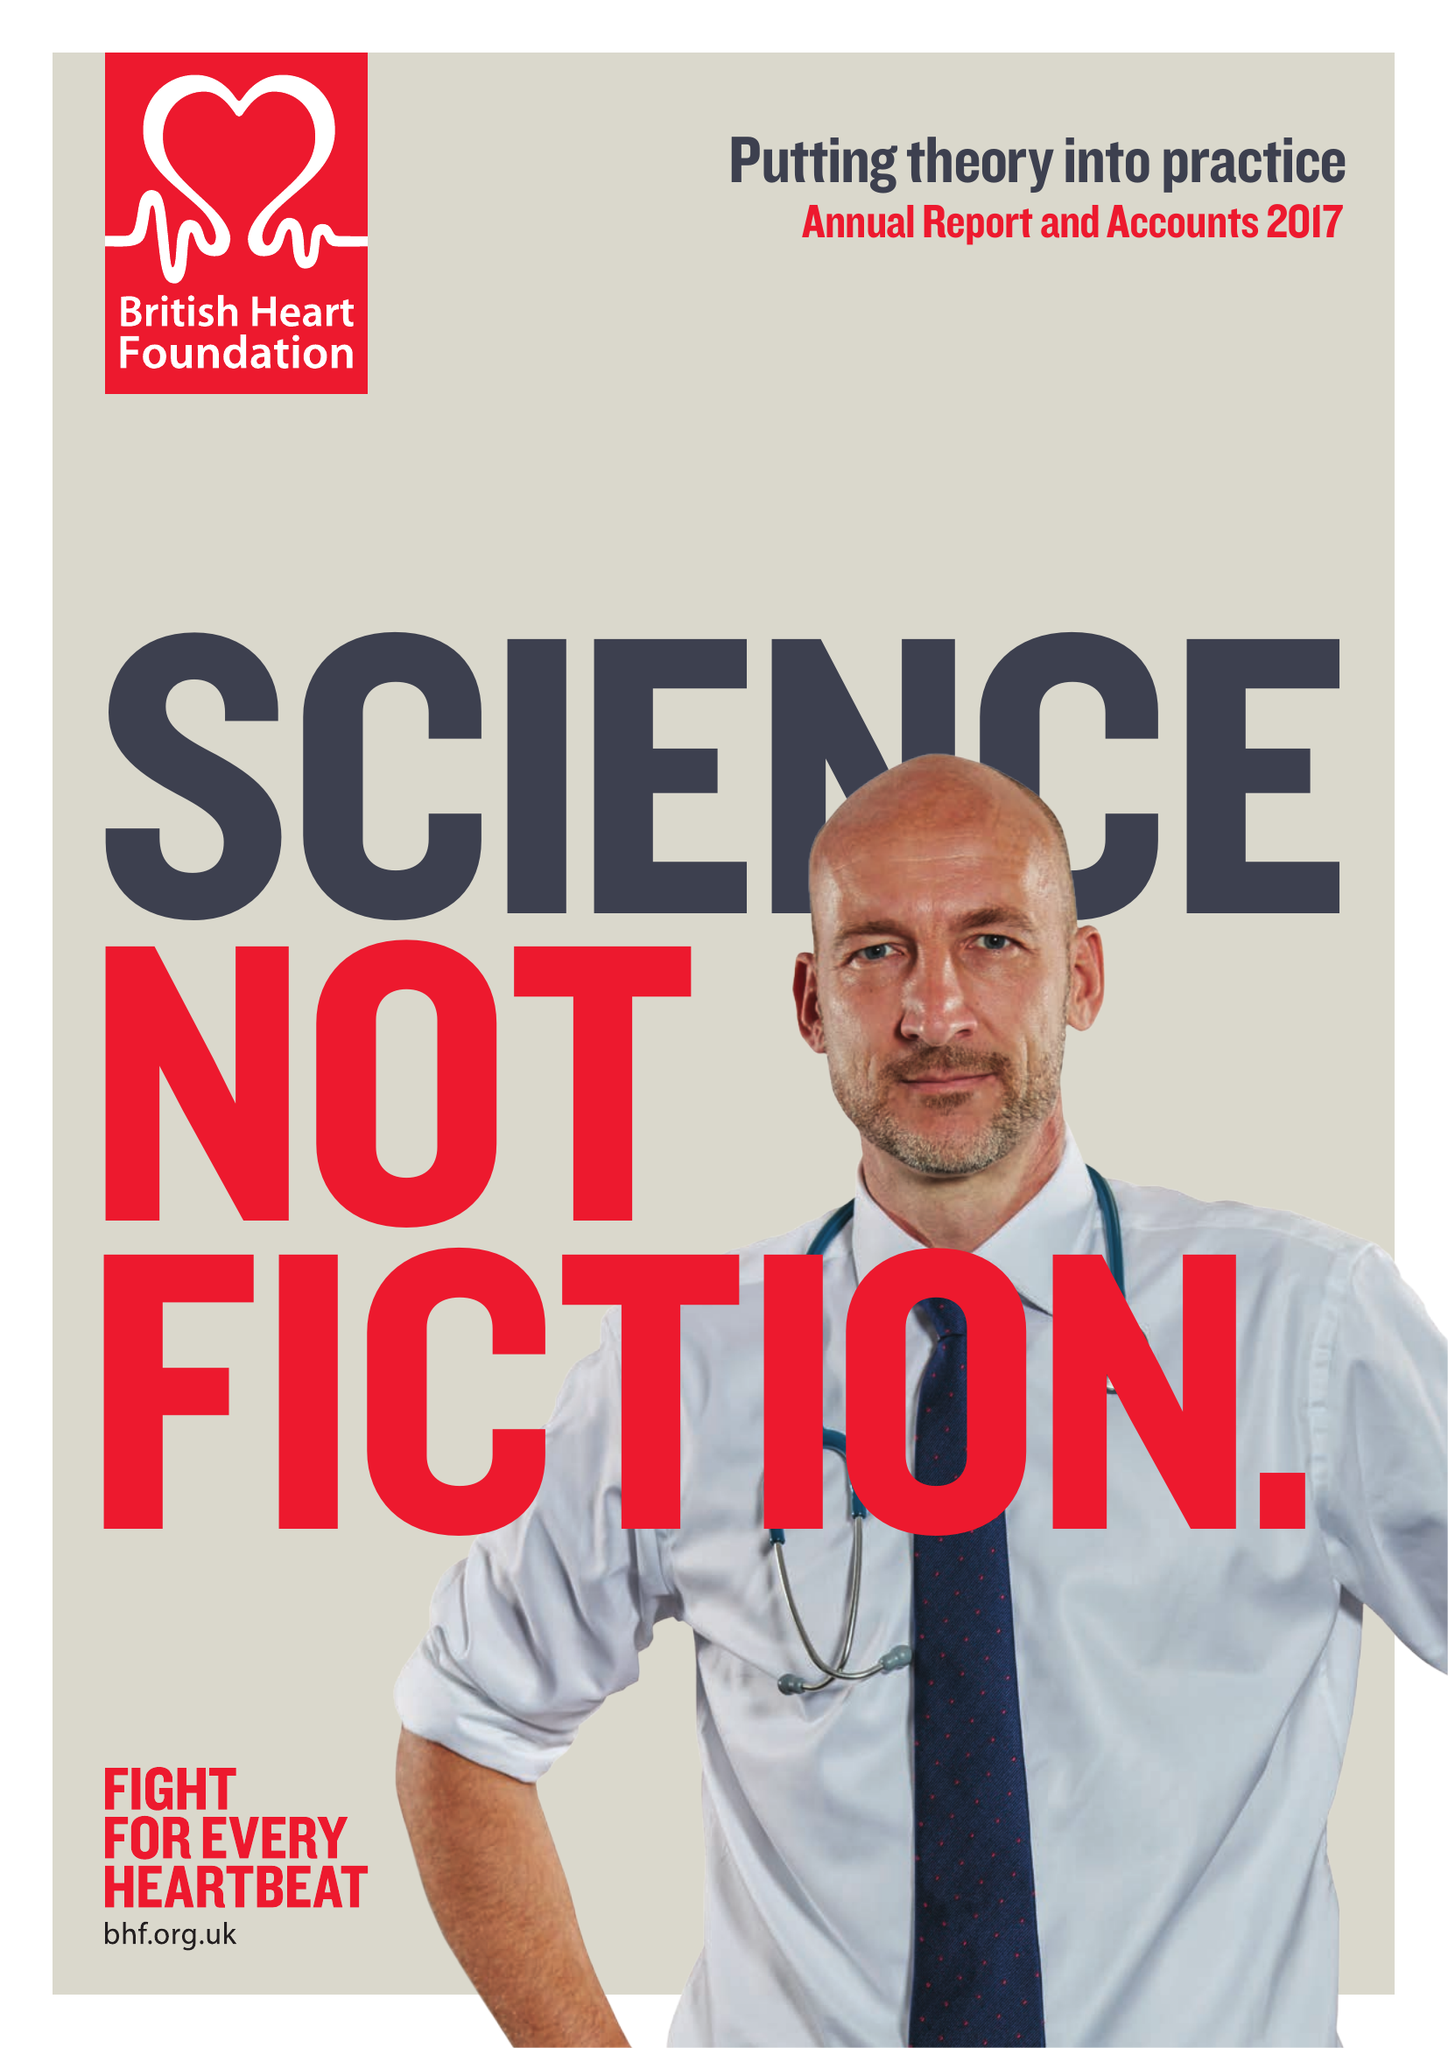What is the value for the report_date?
Answer the question using a single word or phrase. 2017-03-31 